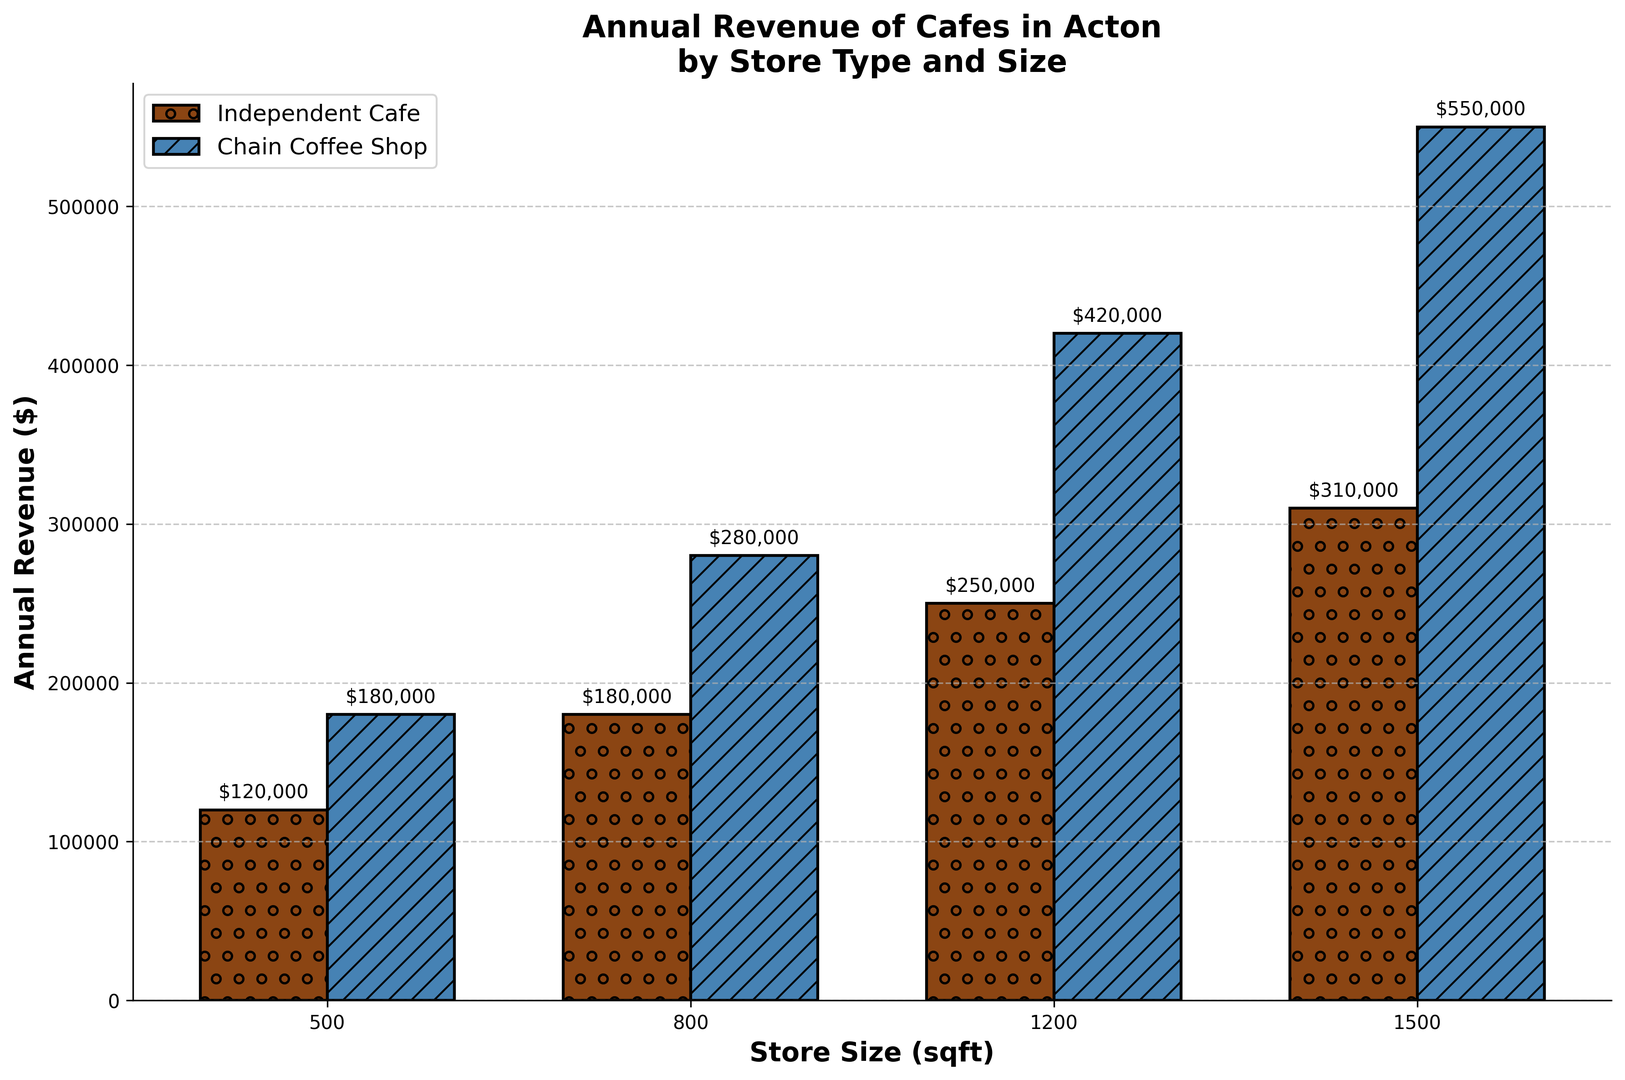What is the annual revenue for an independent cafe of 1200 sqft? Look at the bar corresponding to the 'Independent Cafe' and '1200 sqft'. The bar’s height shows the annual revenue.
Answer: $250,000 How much more annual revenue does a chain coffee shop of 800 sqft generate compared to an independent cafe of the same size? Locate the bars for 'Independent Cafe' and 'Chain Coffee Shop' at the '800 sqft' label. The difference in height indicates the revenue difference: $280,000 (chain) - $180,000 (independent).
Answer: $100,000 Which store type has the highest revenue for a store size of 1500 sqft? Compare the heights of the bars for 'Independent Cafe' and 'Chain Coffee Shop' at the '1500 sqft' label.
Answer: Chain Coffee Shop What is the total annual revenue for independent cafes across all sizes shown? Add the revenue values for independent cafes: $120,000 + $180,000 + $250,000 + $310,000.
Answer: $860,000 Which size of chain coffee shop generates the lowest annual revenue? Compare the heights of all the bars for 'Chain Coffee Shop'. The shortest bar indicates the lowest revenue.
Answer: 500 sqft What is the difference in annual revenue between the smallest independent cafe and the largest chain coffee shop? Subtract the revenue for the smallest independent cafe (500 sqft = $120,000) from the largest chain coffee shop (1500 sqft = $550,000).
Answer: $430,000 By how much does the annual revenue increase for chain coffee shops from 500 sqft to 1500 sqft? Calculate the increase in revenue: $550,000 (1500 sqft) - $180,000 (500 sqft).
Answer: $370,000 What's the average annual revenue for an independent cafe? Calculate the average revenue for independent cafes: ($120,000 + $180,000 + $250,000 + $310,000) / 4.
Answer: $215,000 What is the visual pattern used to represent chain coffee shops? Look at the bars representing 'Chain Coffee Shop' and identify the visual pattern (noting it's described in code as well, but observed visually).
Answer: Diagonal lines 